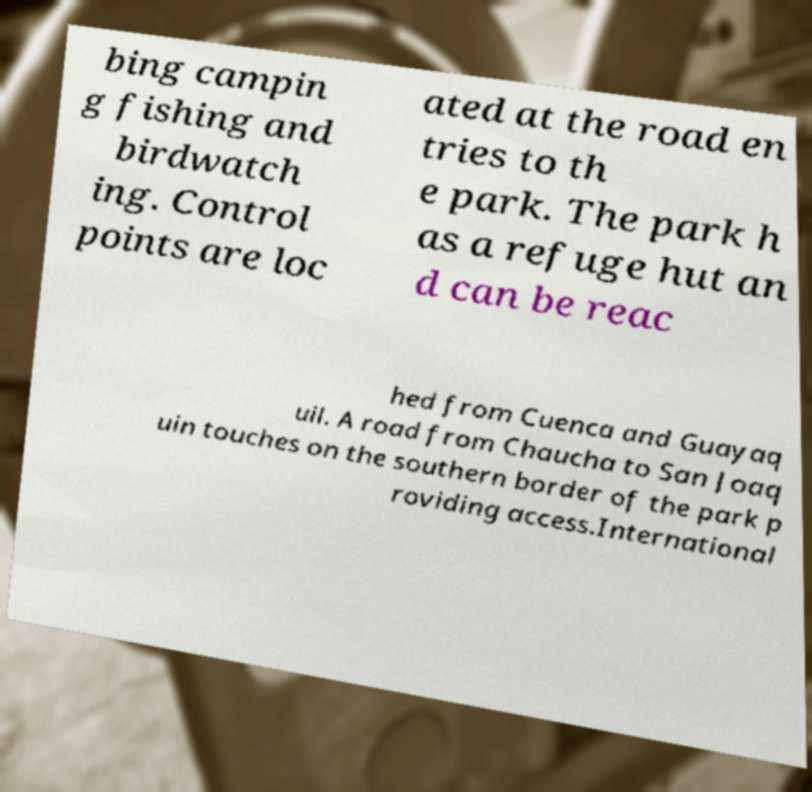Please read and relay the text visible in this image. What does it say? bing campin g fishing and birdwatch ing. Control points are loc ated at the road en tries to th e park. The park h as a refuge hut an d can be reac hed from Cuenca and Guayaq uil. A road from Chaucha to San Joaq uin touches on the southern border of the park p roviding access.International 